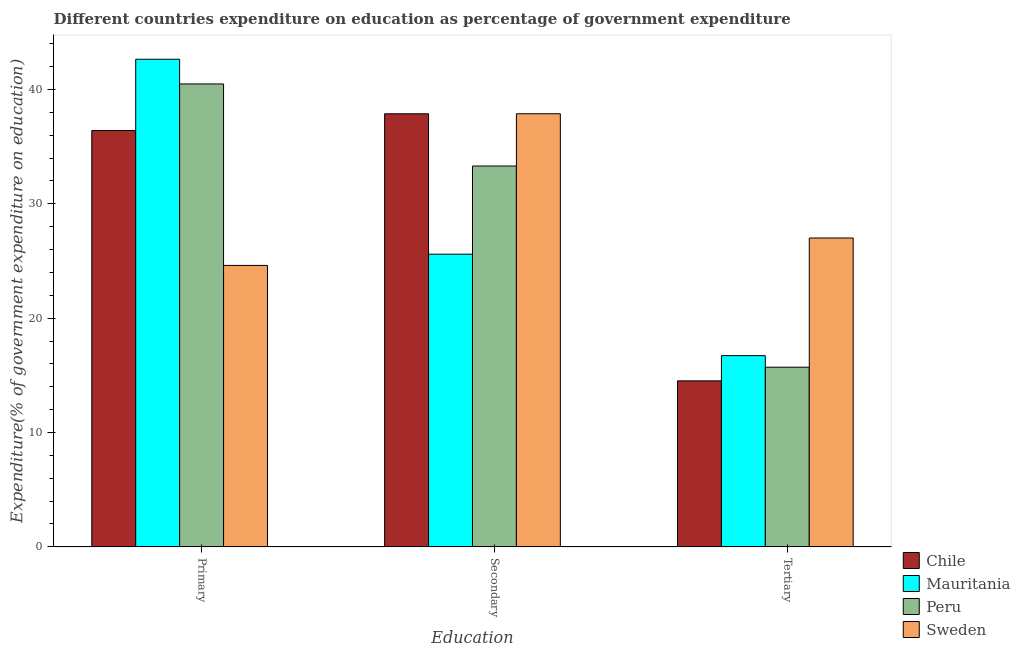How many different coloured bars are there?
Offer a very short reply. 4. Are the number of bars per tick equal to the number of legend labels?
Offer a very short reply. Yes. Are the number of bars on each tick of the X-axis equal?
Your response must be concise. Yes. How many bars are there on the 3rd tick from the left?
Provide a succinct answer. 4. What is the label of the 1st group of bars from the left?
Your response must be concise. Primary. What is the expenditure on secondary education in Chile?
Provide a short and direct response. 37.87. Across all countries, what is the maximum expenditure on primary education?
Give a very brief answer. 42.64. Across all countries, what is the minimum expenditure on primary education?
Provide a succinct answer. 24.61. In which country was the expenditure on tertiary education maximum?
Keep it short and to the point. Sweden. What is the total expenditure on primary education in the graph?
Your response must be concise. 144.13. What is the difference between the expenditure on primary education in Mauritania and that in Sweden?
Offer a very short reply. 18.03. What is the difference between the expenditure on secondary education in Mauritania and the expenditure on primary education in Peru?
Give a very brief answer. -14.89. What is the average expenditure on primary education per country?
Your response must be concise. 36.03. What is the difference between the expenditure on primary education and expenditure on tertiary education in Peru?
Your response must be concise. 24.77. In how many countries, is the expenditure on tertiary education greater than 28 %?
Give a very brief answer. 0. What is the ratio of the expenditure on tertiary education in Chile to that in Mauritania?
Offer a very short reply. 0.87. Is the difference between the expenditure on primary education in Peru and Sweden greater than the difference between the expenditure on secondary education in Peru and Sweden?
Make the answer very short. Yes. What is the difference between the highest and the second highest expenditure on secondary education?
Your response must be concise. 0. What is the difference between the highest and the lowest expenditure on tertiary education?
Your response must be concise. 12.49. Are the values on the major ticks of Y-axis written in scientific E-notation?
Keep it short and to the point. No. Where does the legend appear in the graph?
Your response must be concise. Bottom right. How many legend labels are there?
Offer a very short reply. 4. What is the title of the graph?
Offer a terse response. Different countries expenditure on education as percentage of government expenditure. What is the label or title of the X-axis?
Your response must be concise. Education. What is the label or title of the Y-axis?
Provide a short and direct response. Expenditure(% of government expenditure on education). What is the Expenditure(% of government expenditure on education) of Chile in Primary?
Your response must be concise. 36.4. What is the Expenditure(% of government expenditure on education) in Mauritania in Primary?
Your answer should be very brief. 42.64. What is the Expenditure(% of government expenditure on education) of Peru in Primary?
Provide a short and direct response. 40.48. What is the Expenditure(% of government expenditure on education) of Sweden in Primary?
Provide a succinct answer. 24.61. What is the Expenditure(% of government expenditure on education) in Chile in Secondary?
Your response must be concise. 37.87. What is the Expenditure(% of government expenditure on education) in Mauritania in Secondary?
Your response must be concise. 25.59. What is the Expenditure(% of government expenditure on education) of Peru in Secondary?
Offer a very short reply. 33.3. What is the Expenditure(% of government expenditure on education) of Sweden in Secondary?
Ensure brevity in your answer.  37.87. What is the Expenditure(% of government expenditure on education) in Chile in Tertiary?
Offer a very short reply. 14.51. What is the Expenditure(% of government expenditure on education) of Mauritania in Tertiary?
Make the answer very short. 16.72. What is the Expenditure(% of government expenditure on education) of Peru in Tertiary?
Offer a very short reply. 15.71. What is the Expenditure(% of government expenditure on education) in Sweden in Tertiary?
Make the answer very short. 27.01. Across all Education, what is the maximum Expenditure(% of government expenditure on education) of Chile?
Provide a succinct answer. 37.87. Across all Education, what is the maximum Expenditure(% of government expenditure on education) in Mauritania?
Your answer should be compact. 42.64. Across all Education, what is the maximum Expenditure(% of government expenditure on education) in Peru?
Offer a very short reply. 40.48. Across all Education, what is the maximum Expenditure(% of government expenditure on education) of Sweden?
Provide a succinct answer. 37.87. Across all Education, what is the minimum Expenditure(% of government expenditure on education) in Chile?
Keep it short and to the point. 14.51. Across all Education, what is the minimum Expenditure(% of government expenditure on education) of Mauritania?
Your response must be concise. 16.72. Across all Education, what is the minimum Expenditure(% of government expenditure on education) of Peru?
Your answer should be compact. 15.71. Across all Education, what is the minimum Expenditure(% of government expenditure on education) in Sweden?
Provide a short and direct response. 24.61. What is the total Expenditure(% of government expenditure on education) in Chile in the graph?
Provide a succinct answer. 88.79. What is the total Expenditure(% of government expenditure on education) in Mauritania in the graph?
Your answer should be compact. 84.95. What is the total Expenditure(% of government expenditure on education) in Peru in the graph?
Keep it short and to the point. 89.49. What is the total Expenditure(% of government expenditure on education) in Sweden in the graph?
Provide a short and direct response. 89.49. What is the difference between the Expenditure(% of government expenditure on education) of Chile in Primary and that in Secondary?
Give a very brief answer. -1.46. What is the difference between the Expenditure(% of government expenditure on education) in Mauritania in Primary and that in Secondary?
Provide a short and direct response. 17.05. What is the difference between the Expenditure(% of government expenditure on education) in Peru in Primary and that in Secondary?
Offer a very short reply. 7.18. What is the difference between the Expenditure(% of government expenditure on education) in Sweden in Primary and that in Secondary?
Your answer should be compact. -13.26. What is the difference between the Expenditure(% of government expenditure on education) in Chile in Primary and that in Tertiary?
Give a very brief answer. 21.89. What is the difference between the Expenditure(% of government expenditure on education) in Mauritania in Primary and that in Tertiary?
Your answer should be very brief. 25.92. What is the difference between the Expenditure(% of government expenditure on education) in Peru in Primary and that in Tertiary?
Provide a succinct answer. 24.77. What is the difference between the Expenditure(% of government expenditure on education) in Sweden in Primary and that in Tertiary?
Make the answer very short. -2.4. What is the difference between the Expenditure(% of government expenditure on education) of Chile in Secondary and that in Tertiary?
Provide a succinct answer. 23.35. What is the difference between the Expenditure(% of government expenditure on education) in Mauritania in Secondary and that in Tertiary?
Provide a short and direct response. 8.87. What is the difference between the Expenditure(% of government expenditure on education) in Peru in Secondary and that in Tertiary?
Offer a very short reply. 17.59. What is the difference between the Expenditure(% of government expenditure on education) of Sweden in Secondary and that in Tertiary?
Give a very brief answer. 10.86. What is the difference between the Expenditure(% of government expenditure on education) in Chile in Primary and the Expenditure(% of government expenditure on education) in Mauritania in Secondary?
Ensure brevity in your answer.  10.81. What is the difference between the Expenditure(% of government expenditure on education) of Chile in Primary and the Expenditure(% of government expenditure on education) of Peru in Secondary?
Your response must be concise. 3.1. What is the difference between the Expenditure(% of government expenditure on education) in Chile in Primary and the Expenditure(% of government expenditure on education) in Sweden in Secondary?
Keep it short and to the point. -1.47. What is the difference between the Expenditure(% of government expenditure on education) in Mauritania in Primary and the Expenditure(% of government expenditure on education) in Peru in Secondary?
Provide a succinct answer. 9.34. What is the difference between the Expenditure(% of government expenditure on education) of Mauritania in Primary and the Expenditure(% of government expenditure on education) of Sweden in Secondary?
Keep it short and to the point. 4.77. What is the difference between the Expenditure(% of government expenditure on education) in Peru in Primary and the Expenditure(% of government expenditure on education) in Sweden in Secondary?
Provide a short and direct response. 2.61. What is the difference between the Expenditure(% of government expenditure on education) of Chile in Primary and the Expenditure(% of government expenditure on education) of Mauritania in Tertiary?
Your answer should be compact. 19.68. What is the difference between the Expenditure(% of government expenditure on education) in Chile in Primary and the Expenditure(% of government expenditure on education) in Peru in Tertiary?
Your answer should be compact. 20.7. What is the difference between the Expenditure(% of government expenditure on education) of Chile in Primary and the Expenditure(% of government expenditure on education) of Sweden in Tertiary?
Your answer should be very brief. 9.4. What is the difference between the Expenditure(% of government expenditure on education) of Mauritania in Primary and the Expenditure(% of government expenditure on education) of Peru in Tertiary?
Provide a short and direct response. 26.93. What is the difference between the Expenditure(% of government expenditure on education) in Mauritania in Primary and the Expenditure(% of government expenditure on education) in Sweden in Tertiary?
Your response must be concise. 15.63. What is the difference between the Expenditure(% of government expenditure on education) in Peru in Primary and the Expenditure(% of government expenditure on education) in Sweden in Tertiary?
Your response must be concise. 13.47. What is the difference between the Expenditure(% of government expenditure on education) of Chile in Secondary and the Expenditure(% of government expenditure on education) of Mauritania in Tertiary?
Your response must be concise. 21.15. What is the difference between the Expenditure(% of government expenditure on education) in Chile in Secondary and the Expenditure(% of government expenditure on education) in Peru in Tertiary?
Your response must be concise. 22.16. What is the difference between the Expenditure(% of government expenditure on education) of Chile in Secondary and the Expenditure(% of government expenditure on education) of Sweden in Tertiary?
Make the answer very short. 10.86. What is the difference between the Expenditure(% of government expenditure on education) in Mauritania in Secondary and the Expenditure(% of government expenditure on education) in Peru in Tertiary?
Give a very brief answer. 9.88. What is the difference between the Expenditure(% of government expenditure on education) of Mauritania in Secondary and the Expenditure(% of government expenditure on education) of Sweden in Tertiary?
Make the answer very short. -1.41. What is the difference between the Expenditure(% of government expenditure on education) of Peru in Secondary and the Expenditure(% of government expenditure on education) of Sweden in Tertiary?
Ensure brevity in your answer.  6.3. What is the average Expenditure(% of government expenditure on education) of Chile per Education?
Your answer should be very brief. 29.6. What is the average Expenditure(% of government expenditure on education) of Mauritania per Education?
Ensure brevity in your answer.  28.32. What is the average Expenditure(% of government expenditure on education) in Peru per Education?
Provide a succinct answer. 29.83. What is the average Expenditure(% of government expenditure on education) in Sweden per Education?
Ensure brevity in your answer.  29.83. What is the difference between the Expenditure(% of government expenditure on education) in Chile and Expenditure(% of government expenditure on education) in Mauritania in Primary?
Ensure brevity in your answer.  -6.23. What is the difference between the Expenditure(% of government expenditure on education) of Chile and Expenditure(% of government expenditure on education) of Peru in Primary?
Offer a very short reply. -4.07. What is the difference between the Expenditure(% of government expenditure on education) of Chile and Expenditure(% of government expenditure on education) of Sweden in Primary?
Provide a succinct answer. 11.79. What is the difference between the Expenditure(% of government expenditure on education) in Mauritania and Expenditure(% of government expenditure on education) in Peru in Primary?
Your answer should be compact. 2.16. What is the difference between the Expenditure(% of government expenditure on education) of Mauritania and Expenditure(% of government expenditure on education) of Sweden in Primary?
Ensure brevity in your answer.  18.03. What is the difference between the Expenditure(% of government expenditure on education) in Peru and Expenditure(% of government expenditure on education) in Sweden in Primary?
Give a very brief answer. 15.87. What is the difference between the Expenditure(% of government expenditure on education) in Chile and Expenditure(% of government expenditure on education) in Mauritania in Secondary?
Give a very brief answer. 12.28. What is the difference between the Expenditure(% of government expenditure on education) of Chile and Expenditure(% of government expenditure on education) of Peru in Secondary?
Your answer should be very brief. 4.57. What is the difference between the Expenditure(% of government expenditure on education) of Chile and Expenditure(% of government expenditure on education) of Sweden in Secondary?
Give a very brief answer. -0. What is the difference between the Expenditure(% of government expenditure on education) in Mauritania and Expenditure(% of government expenditure on education) in Peru in Secondary?
Your answer should be compact. -7.71. What is the difference between the Expenditure(% of government expenditure on education) in Mauritania and Expenditure(% of government expenditure on education) in Sweden in Secondary?
Your answer should be very brief. -12.28. What is the difference between the Expenditure(% of government expenditure on education) of Peru and Expenditure(% of government expenditure on education) of Sweden in Secondary?
Offer a terse response. -4.57. What is the difference between the Expenditure(% of government expenditure on education) of Chile and Expenditure(% of government expenditure on education) of Mauritania in Tertiary?
Ensure brevity in your answer.  -2.21. What is the difference between the Expenditure(% of government expenditure on education) in Chile and Expenditure(% of government expenditure on education) in Peru in Tertiary?
Ensure brevity in your answer.  -1.19. What is the difference between the Expenditure(% of government expenditure on education) in Chile and Expenditure(% of government expenditure on education) in Sweden in Tertiary?
Your answer should be very brief. -12.49. What is the difference between the Expenditure(% of government expenditure on education) in Mauritania and Expenditure(% of government expenditure on education) in Sweden in Tertiary?
Offer a terse response. -10.29. What is the difference between the Expenditure(% of government expenditure on education) in Peru and Expenditure(% of government expenditure on education) in Sweden in Tertiary?
Offer a terse response. -11.3. What is the ratio of the Expenditure(% of government expenditure on education) of Chile in Primary to that in Secondary?
Offer a terse response. 0.96. What is the ratio of the Expenditure(% of government expenditure on education) in Mauritania in Primary to that in Secondary?
Your answer should be compact. 1.67. What is the ratio of the Expenditure(% of government expenditure on education) in Peru in Primary to that in Secondary?
Offer a terse response. 1.22. What is the ratio of the Expenditure(% of government expenditure on education) in Sweden in Primary to that in Secondary?
Give a very brief answer. 0.65. What is the ratio of the Expenditure(% of government expenditure on education) of Chile in Primary to that in Tertiary?
Your response must be concise. 2.51. What is the ratio of the Expenditure(% of government expenditure on education) in Mauritania in Primary to that in Tertiary?
Offer a very short reply. 2.55. What is the ratio of the Expenditure(% of government expenditure on education) in Peru in Primary to that in Tertiary?
Provide a short and direct response. 2.58. What is the ratio of the Expenditure(% of government expenditure on education) in Sweden in Primary to that in Tertiary?
Your answer should be compact. 0.91. What is the ratio of the Expenditure(% of government expenditure on education) in Chile in Secondary to that in Tertiary?
Your response must be concise. 2.61. What is the ratio of the Expenditure(% of government expenditure on education) of Mauritania in Secondary to that in Tertiary?
Ensure brevity in your answer.  1.53. What is the ratio of the Expenditure(% of government expenditure on education) of Peru in Secondary to that in Tertiary?
Make the answer very short. 2.12. What is the ratio of the Expenditure(% of government expenditure on education) in Sweden in Secondary to that in Tertiary?
Ensure brevity in your answer.  1.4. What is the difference between the highest and the second highest Expenditure(% of government expenditure on education) in Chile?
Keep it short and to the point. 1.46. What is the difference between the highest and the second highest Expenditure(% of government expenditure on education) of Mauritania?
Your answer should be very brief. 17.05. What is the difference between the highest and the second highest Expenditure(% of government expenditure on education) in Peru?
Offer a very short reply. 7.18. What is the difference between the highest and the second highest Expenditure(% of government expenditure on education) in Sweden?
Provide a short and direct response. 10.86. What is the difference between the highest and the lowest Expenditure(% of government expenditure on education) of Chile?
Make the answer very short. 23.35. What is the difference between the highest and the lowest Expenditure(% of government expenditure on education) in Mauritania?
Provide a succinct answer. 25.92. What is the difference between the highest and the lowest Expenditure(% of government expenditure on education) of Peru?
Ensure brevity in your answer.  24.77. What is the difference between the highest and the lowest Expenditure(% of government expenditure on education) in Sweden?
Your answer should be compact. 13.26. 